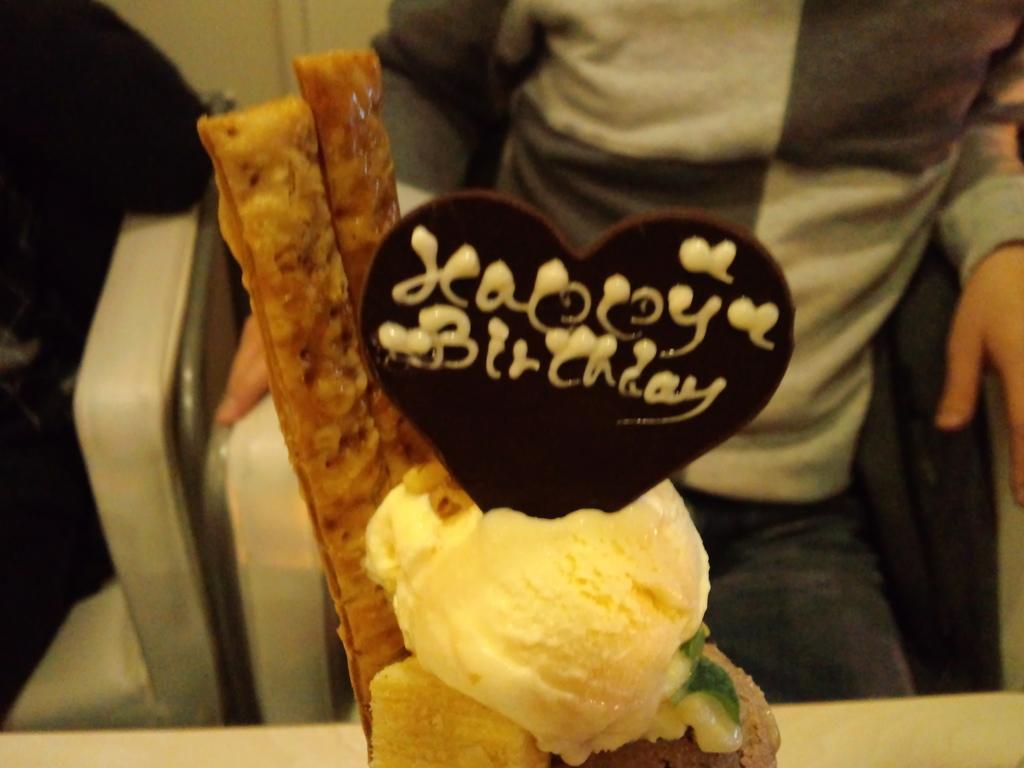Can you describe this image briefly? In this image I can see ice cream which is in cream, brown color. Background I can see a person sitting wearing gray and white shirt. 